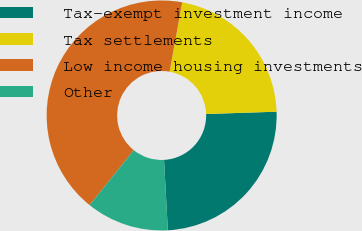Convert chart. <chart><loc_0><loc_0><loc_500><loc_500><pie_chart><fcel>Tax-exempt investment income<fcel>Tax settlements<fcel>Low income housing investments<fcel>Other<nl><fcel>24.66%<fcel>21.62%<fcel>42.09%<fcel>11.63%<nl></chart> 